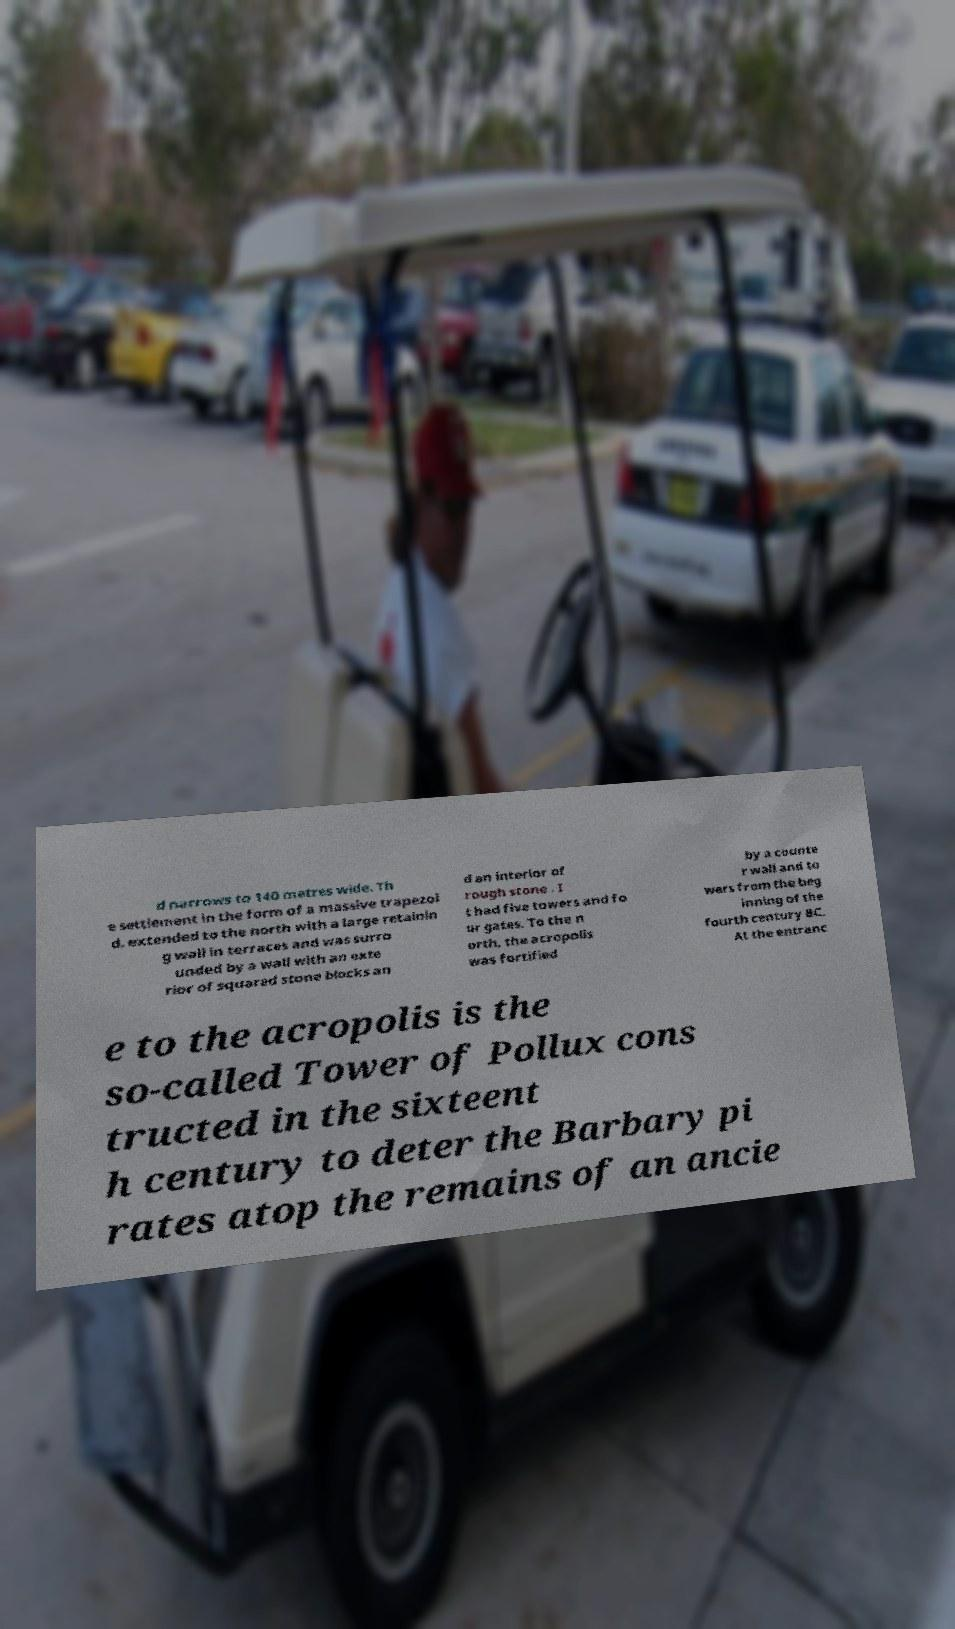Could you extract and type out the text from this image? d narrows to 140 metres wide. Th e settlement in the form of a massive trapezoi d, extended to the north with a large retainin g wall in terraces and was surro unded by a wall with an exte rior of squared stone blocks an d an interior of rough stone . I t had five towers and fo ur gates. To the n orth, the acropolis was fortified by a counte r wall and to wers from the beg inning of the fourth century BC. At the entranc e to the acropolis is the so-called Tower of Pollux cons tructed in the sixteent h century to deter the Barbary pi rates atop the remains of an ancie 